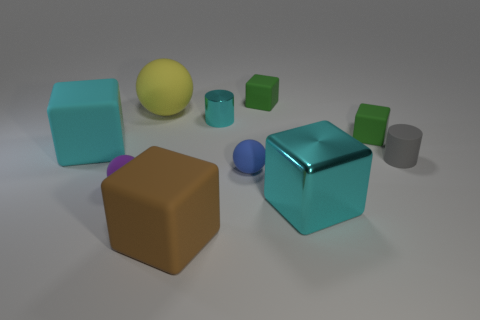What materials are the objects in the image made of? The objects in the image are computer-generated and seem to mimic different materials. The large cube has a metallic cyan surface, implying it is made of metal, while the smaller cube in front of the rubber-like object has a plain, matte finish, suggesting a possible plastic or ceramic composition. The yellow and the smaller cyan spheres look like they could be rubber due to their soft reflections and light diffusion. 